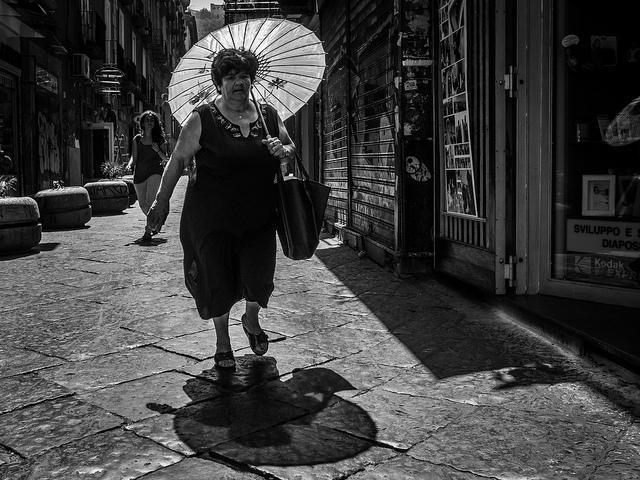How many people are there?
Give a very brief answer. 2. 